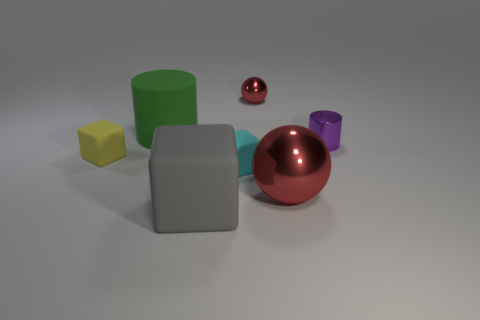Add 2 tiny shiny cylinders. How many objects exist? 9 Subtract all cylinders. How many objects are left? 5 Subtract 0 purple blocks. How many objects are left? 7 Subtract all cyan metal things. Subtract all big matte cylinders. How many objects are left? 6 Add 6 gray rubber cubes. How many gray rubber cubes are left? 7 Add 5 big green balls. How many big green balls exist? 5 